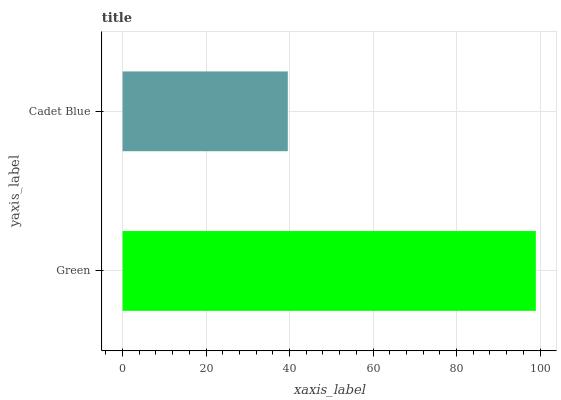Is Cadet Blue the minimum?
Answer yes or no. Yes. Is Green the maximum?
Answer yes or no. Yes. Is Cadet Blue the maximum?
Answer yes or no. No. Is Green greater than Cadet Blue?
Answer yes or no. Yes. Is Cadet Blue less than Green?
Answer yes or no. Yes. Is Cadet Blue greater than Green?
Answer yes or no. No. Is Green less than Cadet Blue?
Answer yes or no. No. Is Green the high median?
Answer yes or no. Yes. Is Cadet Blue the low median?
Answer yes or no. Yes. Is Cadet Blue the high median?
Answer yes or no. No. Is Green the low median?
Answer yes or no. No. 